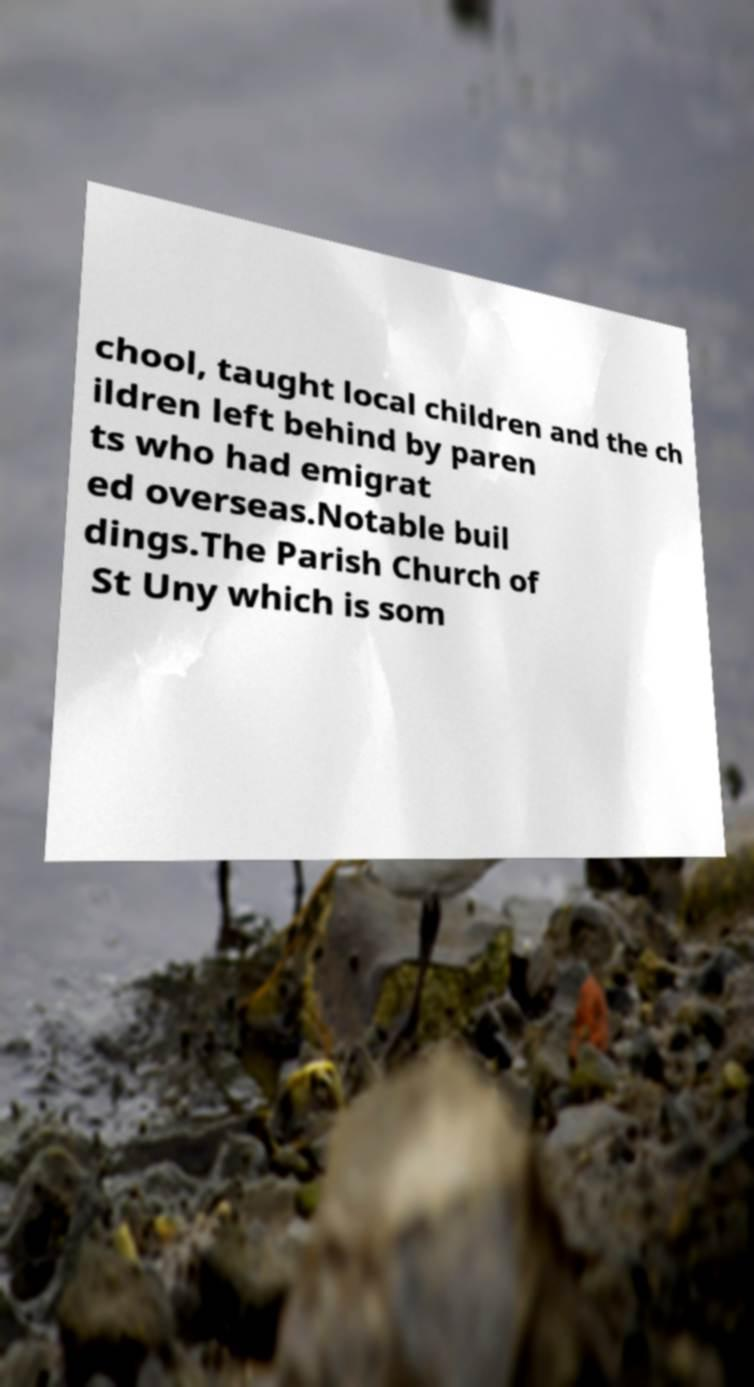Could you assist in decoding the text presented in this image and type it out clearly? chool, taught local children and the ch ildren left behind by paren ts who had emigrat ed overseas.Notable buil dings.The Parish Church of St Uny which is som 